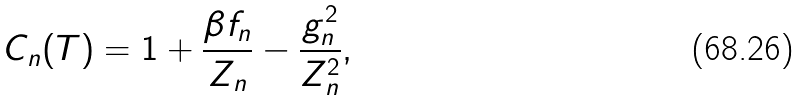<formula> <loc_0><loc_0><loc_500><loc_500>C _ { n } ( T ) = 1 + { \frac { \beta f _ { n } } { Z _ { n } } } - { \frac { g ^ { 2 } _ { n } } { Z ^ { 2 } _ { n } } } ,</formula> 